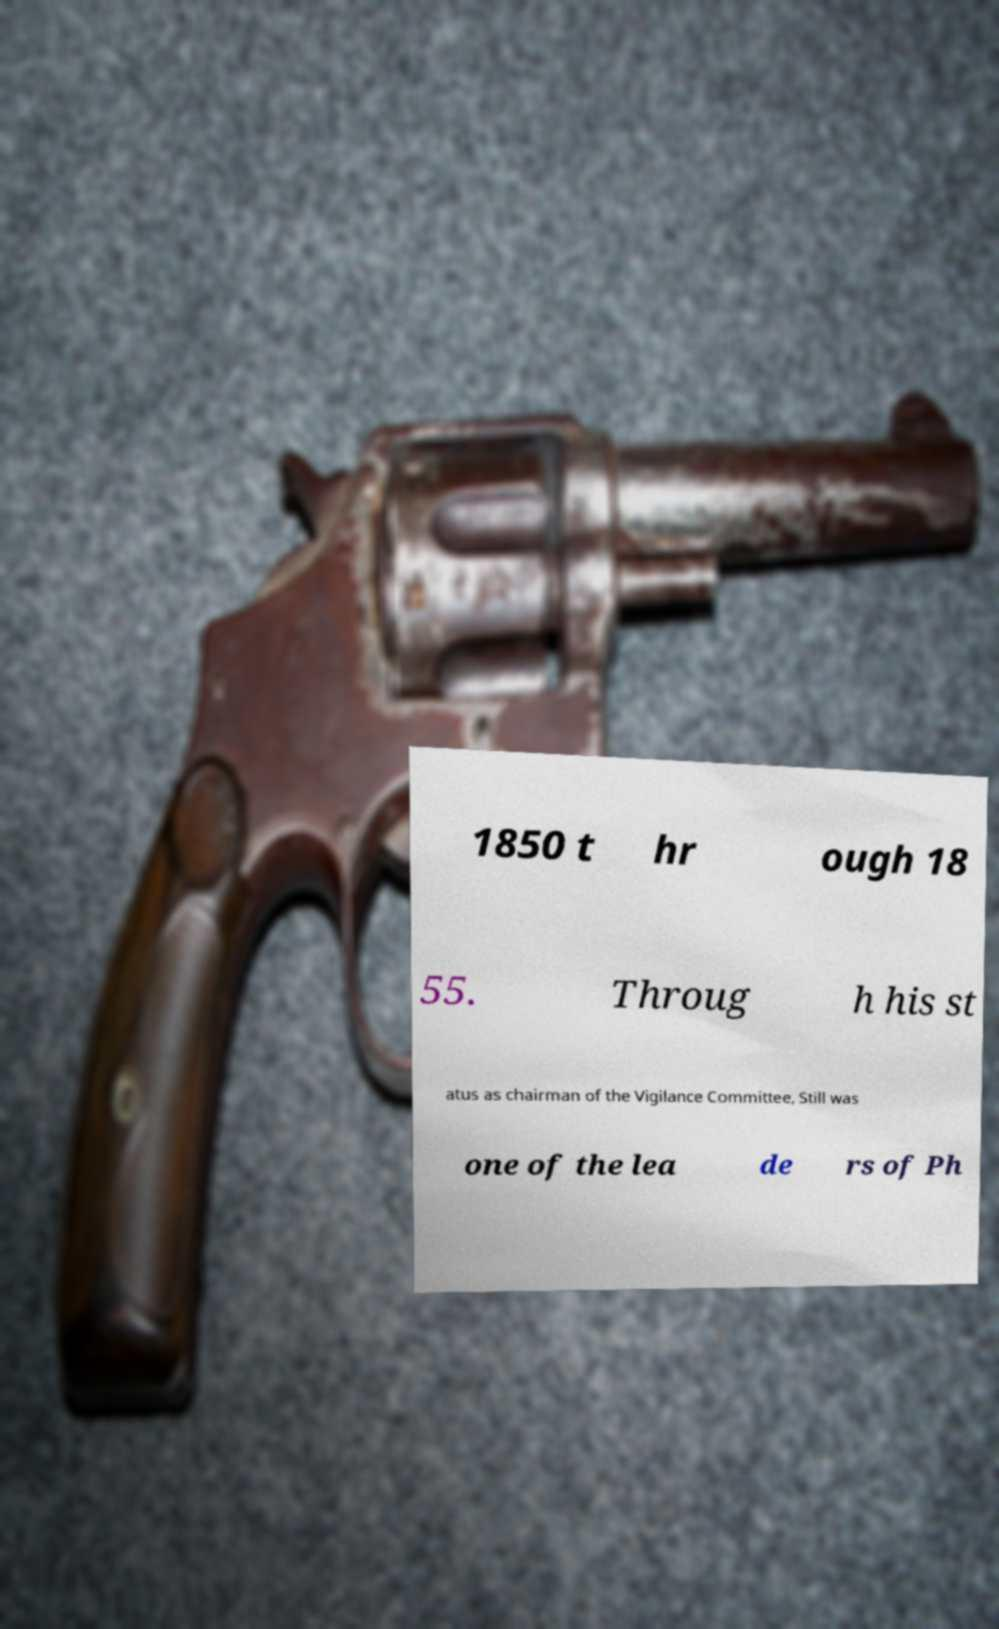Can you accurately transcribe the text from the provided image for me? 1850 t hr ough 18 55. Throug h his st atus as chairman of the Vigilance Committee, Still was one of the lea de rs of Ph 